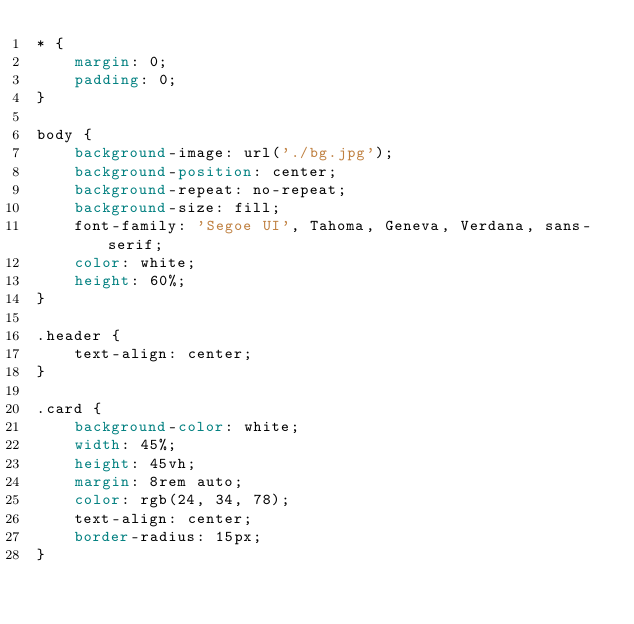<code> <loc_0><loc_0><loc_500><loc_500><_CSS_>* {
    margin: 0;
    padding: 0;
}

body {
    background-image: url('./bg.jpg');
    background-position: center;
    background-repeat: no-repeat;
    background-size: fill;
    font-family: 'Segoe UI', Tahoma, Geneva, Verdana, sans-serif;
    color: white;
    height: 60%;
}

.header {
    text-align: center;
}

.card {
    background-color: white;
    width: 45%;
    height: 45vh;
    margin: 8rem auto;
    color: rgb(24, 34, 78);
    text-align: center;
    border-radius: 15px;
}</code> 